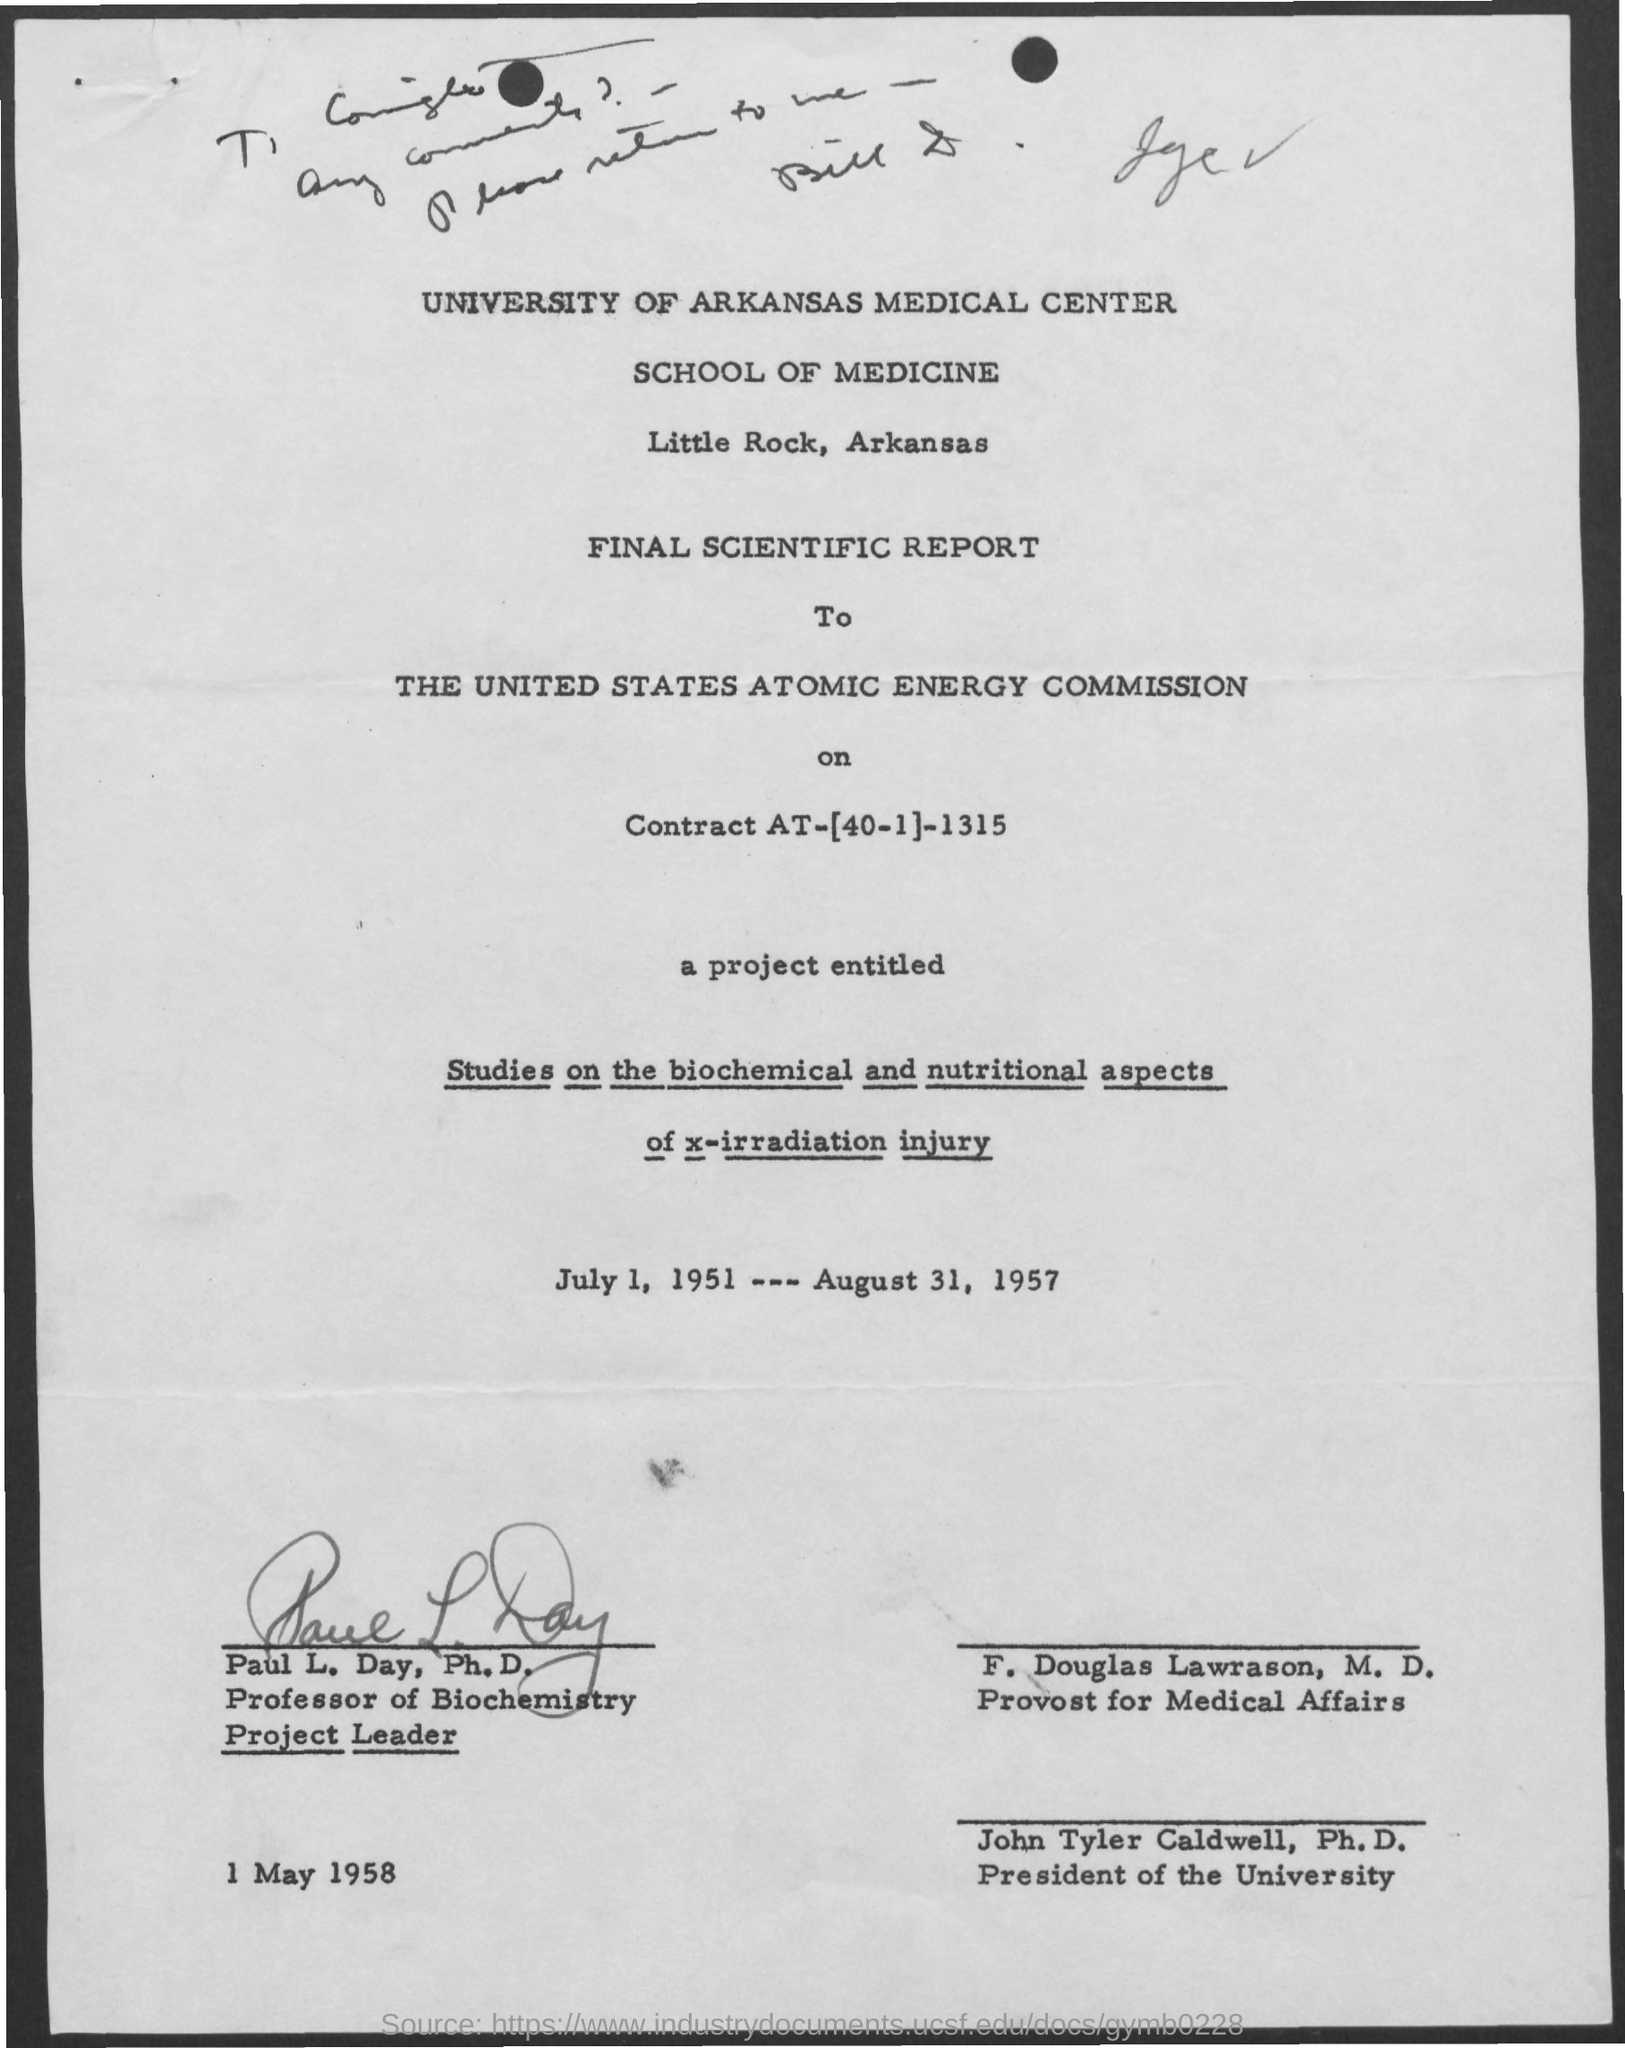What is the Project Timing?
Offer a terse response. July 1, 1951 ---- August 31, 1957. 